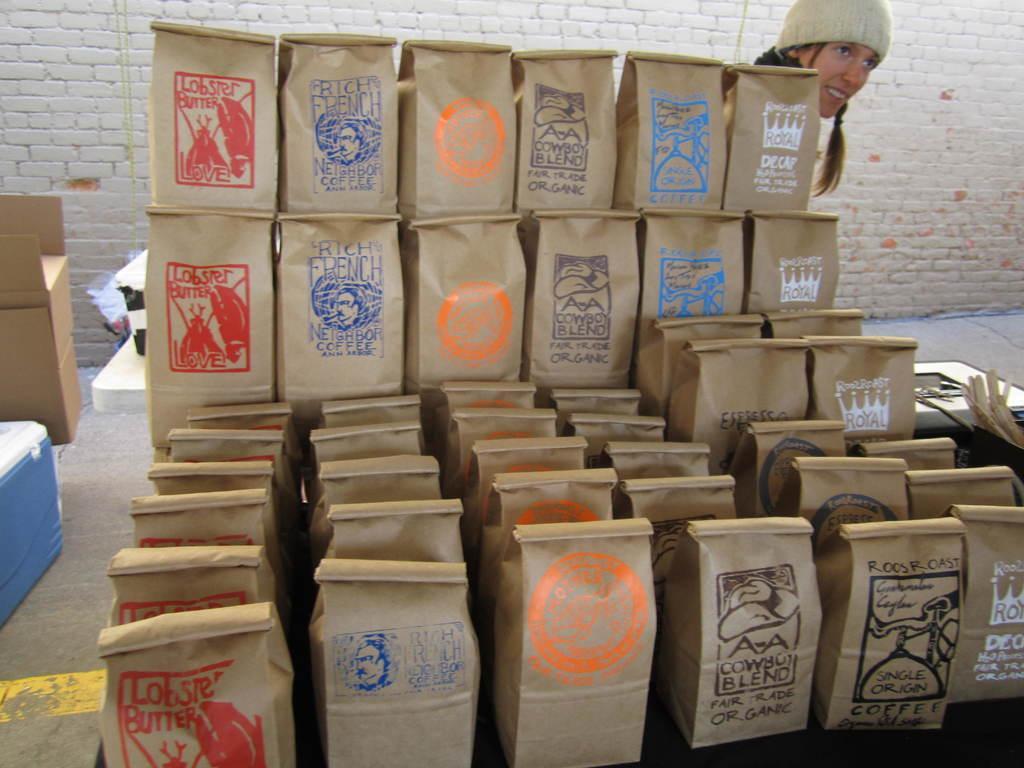Please provide a concise description of this image. In the image we can see these are the paper bags and there is a woman wearing a cap. This is a box, a wall and a floor, this is a yellow line. 